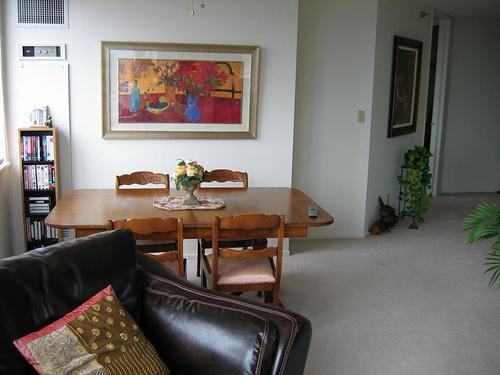How many green plants are in the room?
Give a very brief answer. 2. How many dining tables are there?
Give a very brief answer. 1. How many potted plants are in the picture?
Give a very brief answer. 2. How many chairs are there?
Give a very brief answer. 2. How many hooves does the cow on the right have?
Give a very brief answer. 0. 